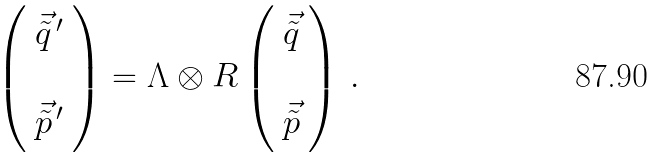Convert formula to latex. <formula><loc_0><loc_0><loc_500><loc_500>\left ( \begin{array} { c } \vec { \tilde { q } } ^ { \, \prime } \\ \\ \vec { \tilde { p } } ^ { \, \prime } \\ \end{array} \right ) = \Lambda \otimes R \left ( \begin{array} { c } \vec { \tilde { q } } \\ \\ \vec { \tilde { p } } \\ \end{array} \right ) \, .</formula> 